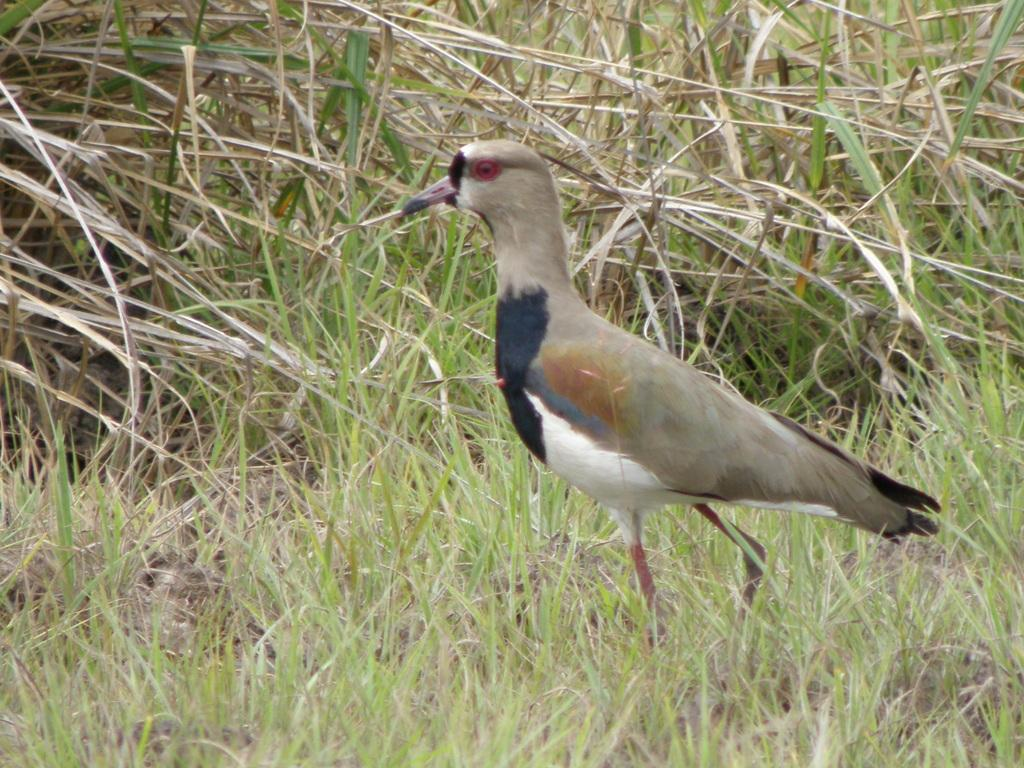What type of animal is on the ground in the image? There is a bird on the ground in the image. What else can be seen in the image besides the bird? There are plants in the image. What color is the bird's sweater in the image? Birds do not wear sweaters, and there is no sweater present in the image. 